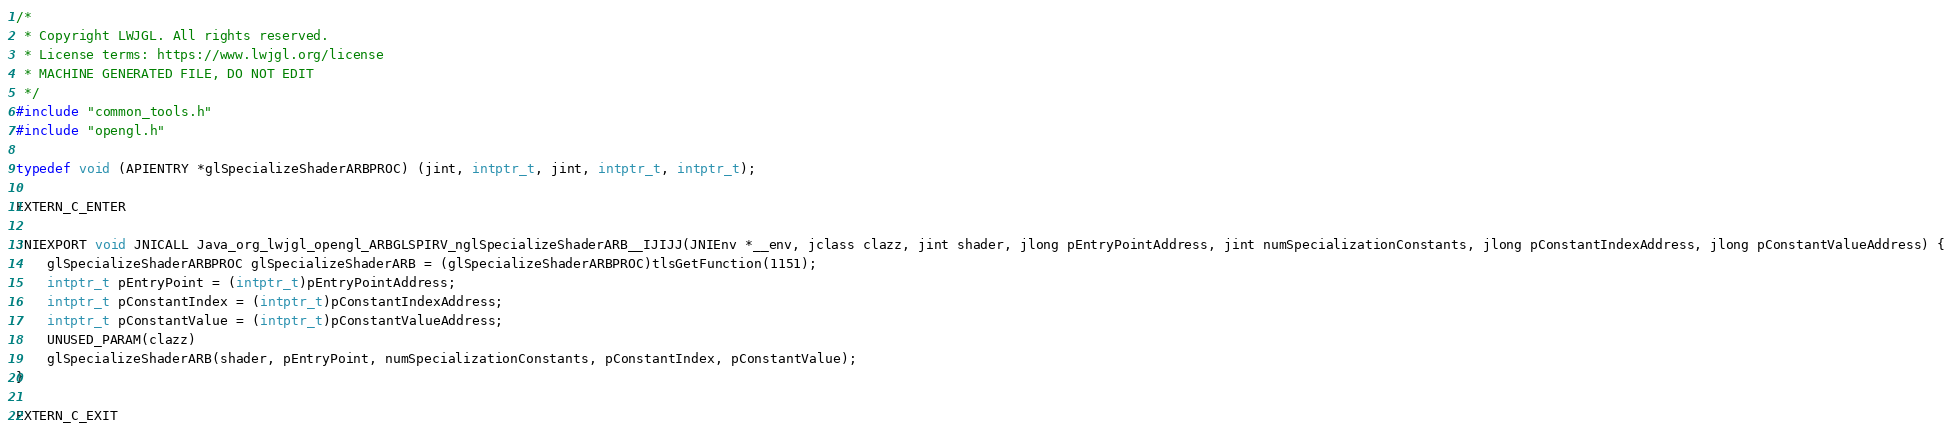<code> <loc_0><loc_0><loc_500><loc_500><_C_>/*
 * Copyright LWJGL. All rights reserved.
 * License terms: https://www.lwjgl.org/license
 * MACHINE GENERATED FILE, DO NOT EDIT
 */
#include "common_tools.h"
#include "opengl.h"

typedef void (APIENTRY *glSpecializeShaderARBPROC) (jint, intptr_t, jint, intptr_t, intptr_t);

EXTERN_C_ENTER

JNIEXPORT void JNICALL Java_org_lwjgl_opengl_ARBGLSPIRV_nglSpecializeShaderARB__IJIJJ(JNIEnv *__env, jclass clazz, jint shader, jlong pEntryPointAddress, jint numSpecializationConstants, jlong pConstantIndexAddress, jlong pConstantValueAddress) {
    glSpecializeShaderARBPROC glSpecializeShaderARB = (glSpecializeShaderARBPROC)tlsGetFunction(1151);
    intptr_t pEntryPoint = (intptr_t)pEntryPointAddress;
    intptr_t pConstantIndex = (intptr_t)pConstantIndexAddress;
    intptr_t pConstantValue = (intptr_t)pConstantValueAddress;
    UNUSED_PARAM(clazz)
    glSpecializeShaderARB(shader, pEntryPoint, numSpecializationConstants, pConstantIndex, pConstantValue);
}

EXTERN_C_EXIT
</code> 